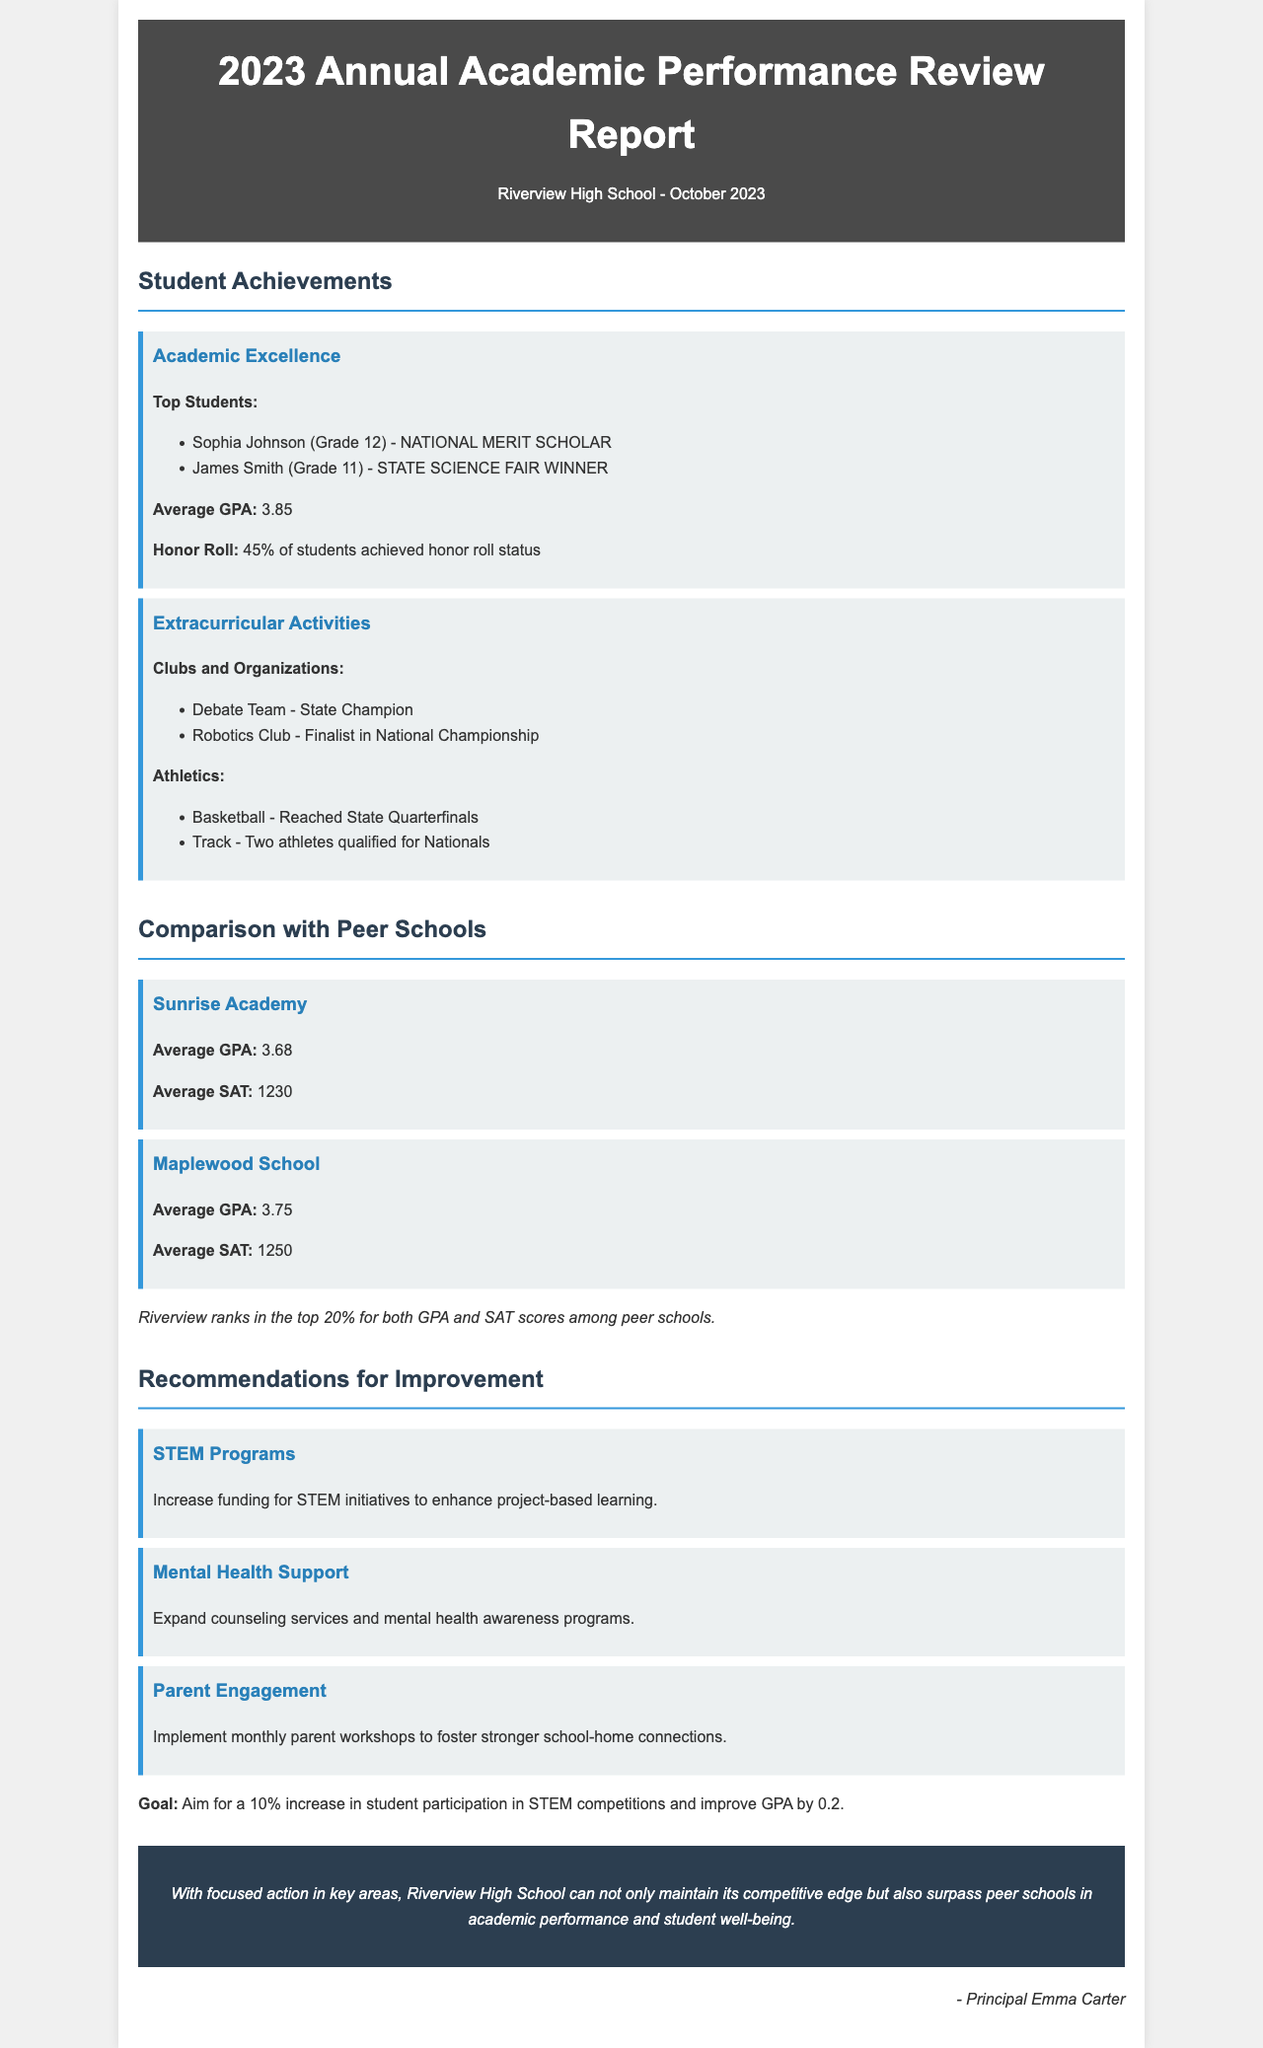What is the average GPA of Riverview High School? The average GPA is stated in the document under Student Achievements.
Answer: 3.85 Who is the National Merit Scholar? The name of the National Merit Scholar is mentioned in the Achievements section.
Answer: Sophia Johnson Which team is mentioned as the State Champion in Extracurricular Activities? The document specifies the Debate Team as the State Champion in the Extracurricular section.
Answer: Debate Team What is the goal for improving student participation in STEM competitions? The goal for improvement is outlined in the Recommendations for Improvement section.
Answer: 10% increase What average SAT score does Maplewood School have? The average SAT score for Maplewood School is listed in the Comparison with Peer Schools section.
Answer: 1250 How many students achieved honor roll status at Riverview High School? The percentage of students on the honor roll is provided in the Achievements section.
Answer: 45% What mental health support recommendation is made in the report? The document provides a specific recommendation under Recommendations for Improvement.
Answer: Expand counseling services In which top percentage does Riverview rank compared to peer schools based on GPA? The ranking information is shared in the Comparison with Peer Schools section.
Answer: Top 20% 